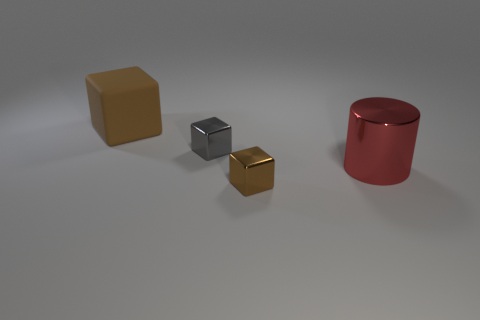How do the objects relate to each other in the space? The objects are spatially separate and distinct, without overlapping. The larger brown cube is set back and in-between the smaller gray and gold cubes, while the red cylinder is placed off to the side. There seems to be an intentional placement to avoid visual clutter and create a sense of balance and order within the scene. 